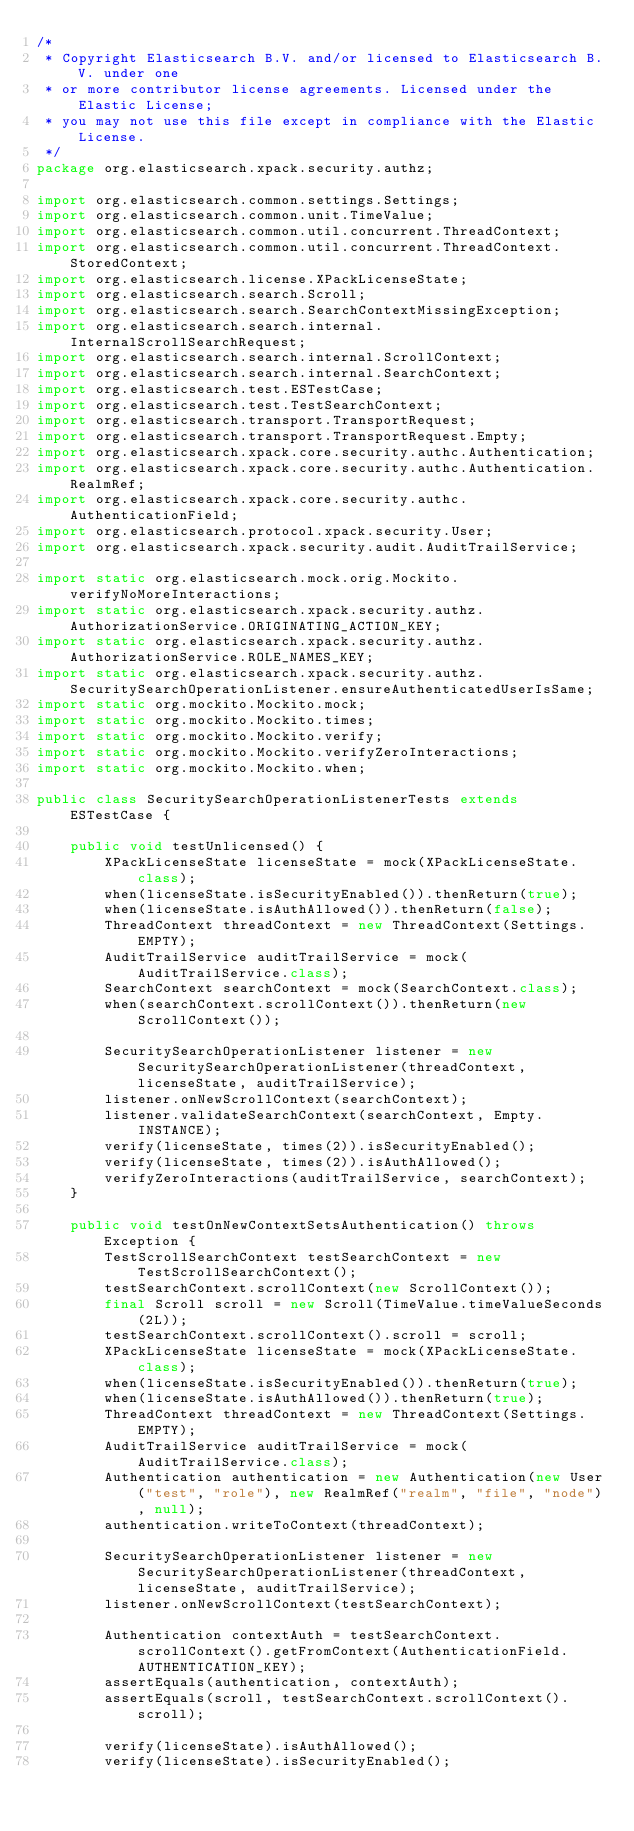Convert code to text. <code><loc_0><loc_0><loc_500><loc_500><_Java_>/*
 * Copyright Elasticsearch B.V. and/or licensed to Elasticsearch B.V. under one
 * or more contributor license agreements. Licensed under the Elastic License;
 * you may not use this file except in compliance with the Elastic License.
 */
package org.elasticsearch.xpack.security.authz;

import org.elasticsearch.common.settings.Settings;
import org.elasticsearch.common.unit.TimeValue;
import org.elasticsearch.common.util.concurrent.ThreadContext;
import org.elasticsearch.common.util.concurrent.ThreadContext.StoredContext;
import org.elasticsearch.license.XPackLicenseState;
import org.elasticsearch.search.Scroll;
import org.elasticsearch.search.SearchContextMissingException;
import org.elasticsearch.search.internal.InternalScrollSearchRequest;
import org.elasticsearch.search.internal.ScrollContext;
import org.elasticsearch.search.internal.SearchContext;
import org.elasticsearch.test.ESTestCase;
import org.elasticsearch.test.TestSearchContext;
import org.elasticsearch.transport.TransportRequest;
import org.elasticsearch.transport.TransportRequest.Empty;
import org.elasticsearch.xpack.core.security.authc.Authentication;
import org.elasticsearch.xpack.core.security.authc.Authentication.RealmRef;
import org.elasticsearch.xpack.core.security.authc.AuthenticationField;
import org.elasticsearch.protocol.xpack.security.User;
import org.elasticsearch.xpack.security.audit.AuditTrailService;

import static org.elasticsearch.mock.orig.Mockito.verifyNoMoreInteractions;
import static org.elasticsearch.xpack.security.authz.AuthorizationService.ORIGINATING_ACTION_KEY;
import static org.elasticsearch.xpack.security.authz.AuthorizationService.ROLE_NAMES_KEY;
import static org.elasticsearch.xpack.security.authz.SecuritySearchOperationListener.ensureAuthenticatedUserIsSame;
import static org.mockito.Mockito.mock;
import static org.mockito.Mockito.times;
import static org.mockito.Mockito.verify;
import static org.mockito.Mockito.verifyZeroInteractions;
import static org.mockito.Mockito.when;

public class SecuritySearchOperationListenerTests extends ESTestCase {

    public void testUnlicensed() {
        XPackLicenseState licenseState = mock(XPackLicenseState.class);
        when(licenseState.isSecurityEnabled()).thenReturn(true);
        when(licenseState.isAuthAllowed()).thenReturn(false);
        ThreadContext threadContext = new ThreadContext(Settings.EMPTY);
        AuditTrailService auditTrailService = mock(AuditTrailService.class);
        SearchContext searchContext = mock(SearchContext.class);
        when(searchContext.scrollContext()).thenReturn(new ScrollContext());

        SecuritySearchOperationListener listener = new SecuritySearchOperationListener(threadContext, licenseState, auditTrailService);
        listener.onNewScrollContext(searchContext);
        listener.validateSearchContext(searchContext, Empty.INSTANCE);
        verify(licenseState, times(2)).isSecurityEnabled();
        verify(licenseState, times(2)).isAuthAllowed();
        verifyZeroInteractions(auditTrailService, searchContext);
    }

    public void testOnNewContextSetsAuthentication() throws Exception {
        TestScrollSearchContext testSearchContext = new TestScrollSearchContext();
        testSearchContext.scrollContext(new ScrollContext());
        final Scroll scroll = new Scroll(TimeValue.timeValueSeconds(2L));
        testSearchContext.scrollContext().scroll = scroll;
        XPackLicenseState licenseState = mock(XPackLicenseState.class);
        when(licenseState.isSecurityEnabled()).thenReturn(true);
        when(licenseState.isAuthAllowed()).thenReturn(true);
        ThreadContext threadContext = new ThreadContext(Settings.EMPTY);
        AuditTrailService auditTrailService = mock(AuditTrailService.class);
        Authentication authentication = new Authentication(new User("test", "role"), new RealmRef("realm", "file", "node"), null);
        authentication.writeToContext(threadContext);

        SecuritySearchOperationListener listener = new SecuritySearchOperationListener(threadContext, licenseState, auditTrailService);
        listener.onNewScrollContext(testSearchContext);

        Authentication contextAuth = testSearchContext.scrollContext().getFromContext(AuthenticationField.AUTHENTICATION_KEY);
        assertEquals(authentication, contextAuth);
        assertEquals(scroll, testSearchContext.scrollContext().scroll);

        verify(licenseState).isAuthAllowed();
        verify(licenseState).isSecurityEnabled();</code> 